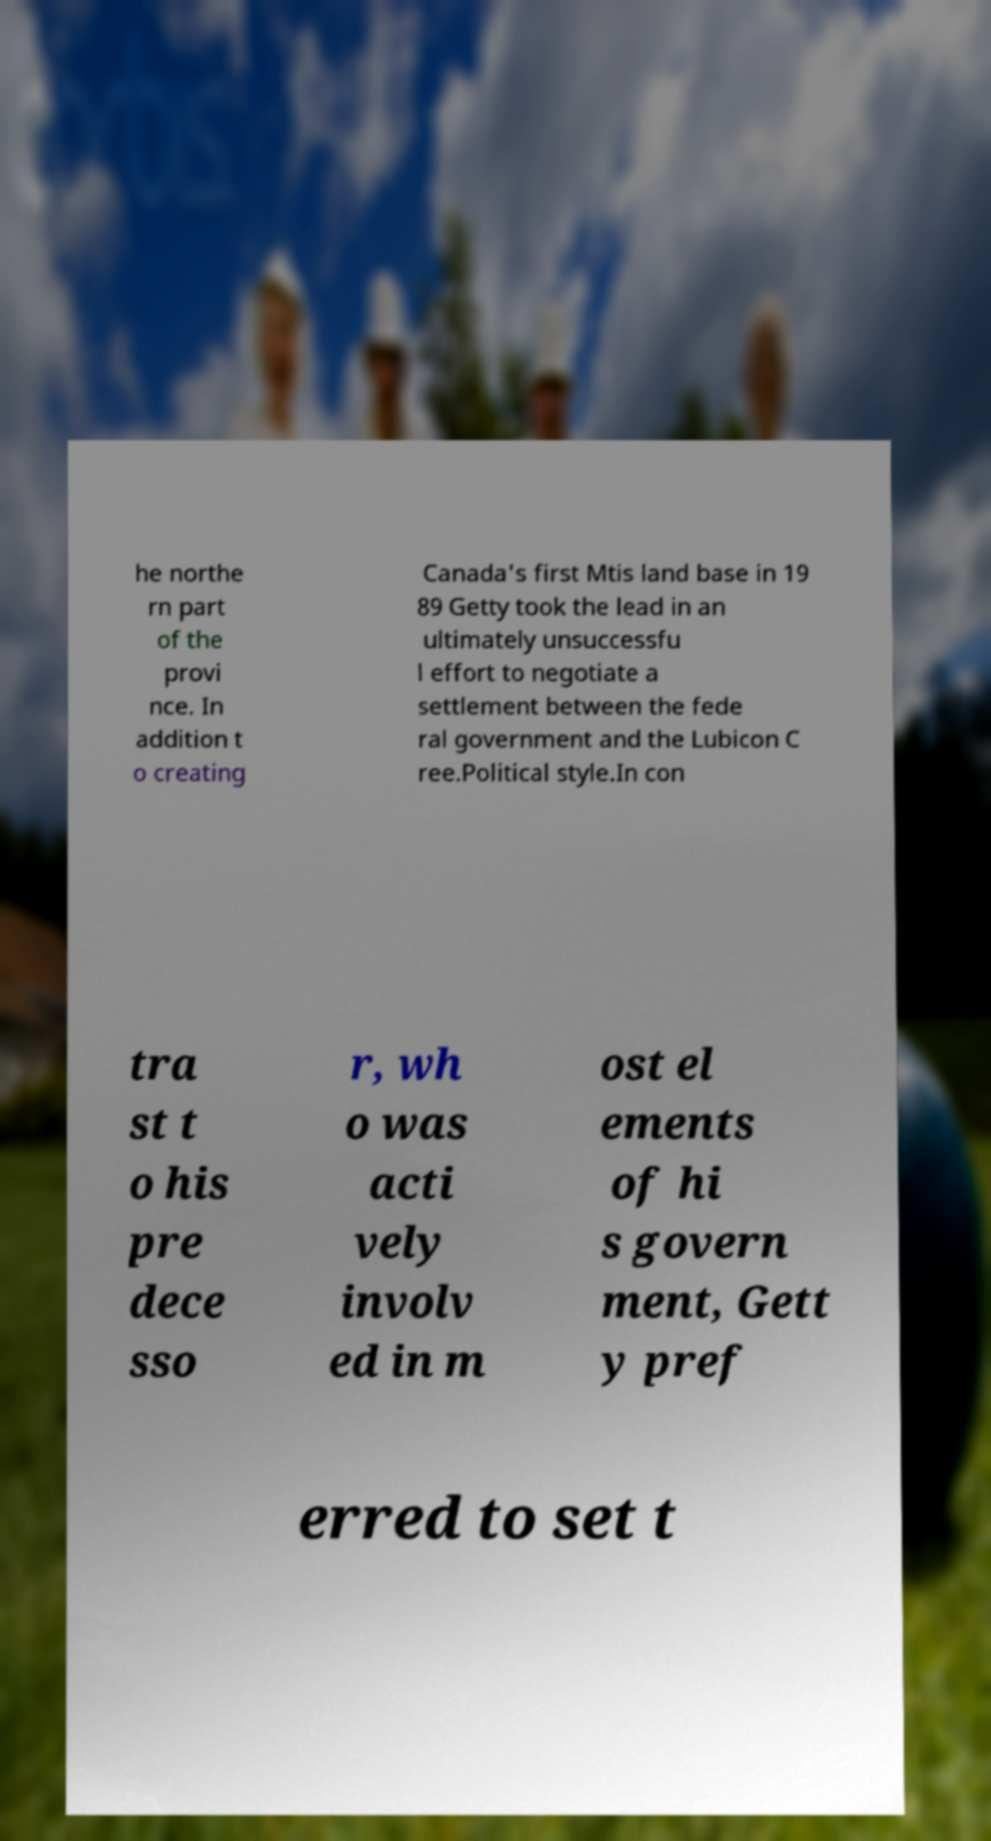For documentation purposes, I need the text within this image transcribed. Could you provide that? he northe rn part of the provi nce. In addition t o creating Canada's first Mtis land base in 19 89 Getty took the lead in an ultimately unsuccessfu l effort to negotiate a settlement between the fede ral government and the Lubicon C ree.Political style.In con tra st t o his pre dece sso r, wh o was acti vely involv ed in m ost el ements of hi s govern ment, Gett y pref erred to set t 